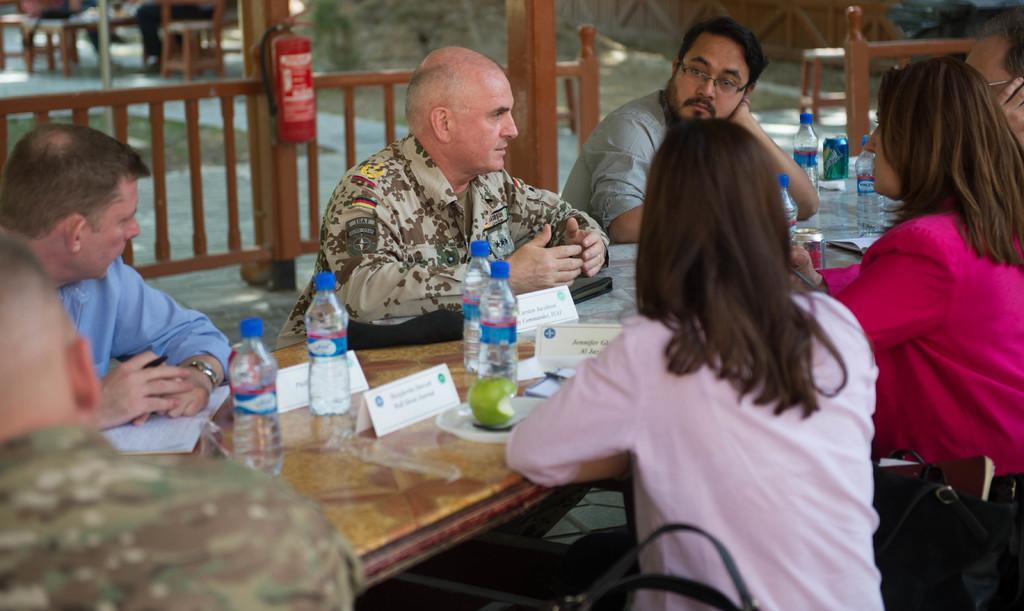Describe this image in one or two sentences. In this picture we can see some persons sitting on chair and in front of them there is table and on table we can see bottles, name boards, plate, papers, tin, fruit on plate and in background we can see fence, fire extinguisher,path. 